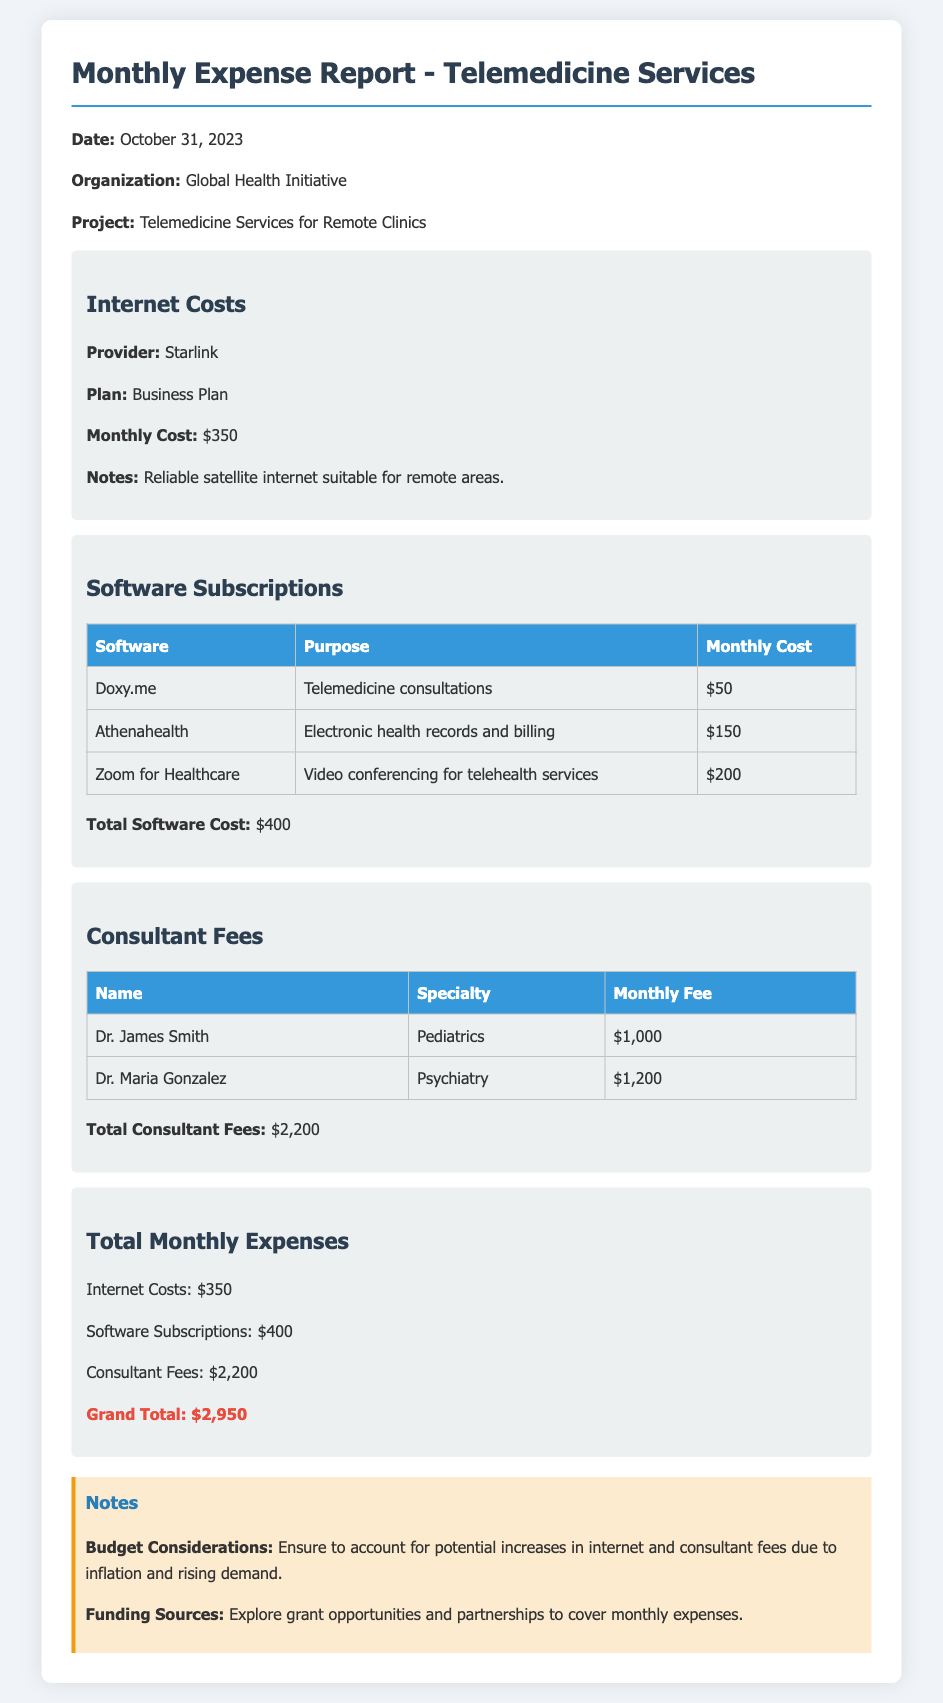What is the monthly cost for internet? The monthly cost for internet, as indicated in the expense report, is $350.
Answer: $350 What is the total cost for software subscriptions? The total cost for software subscriptions can be found by adding the costs of the three software subscriptions listed, which equals $400.
Answer: $400 Who is the specialist in Psychiatry? The document lists Dr. Maria Gonzalez as the specialist in Psychiatry under consultant fees.
Answer: Dr. Maria Gonzalez What is the grand total of monthly expenses? The grand total of monthly expenses is clearly stated in the document at the end of the expense section, which is $2,950.
Answer: $2,950 What is the total for consultant fees? The total for consultant fees is calculated by summing the monthly fees of Dr. James Smith and Dr. Maria Gonzalez, resulting in $2,200.
Answer: $2,200 What type of plan does Starlink provide? The plan provided by Starlink is described as a Business Plan in the internet costs section.
Answer: Business Plan What is the purpose of Zoom for Healthcare? The document specifies that Zoom for Healthcare is used for video conferencing for telehealth services.
Answer: Video conferencing for telehealth services What recommendations are made regarding budget considerations? The notes section contains a recommendation to account for potential increases in costs due to inflation and rising demand.
Answer: Account for potential increases due to inflation and rising demand 